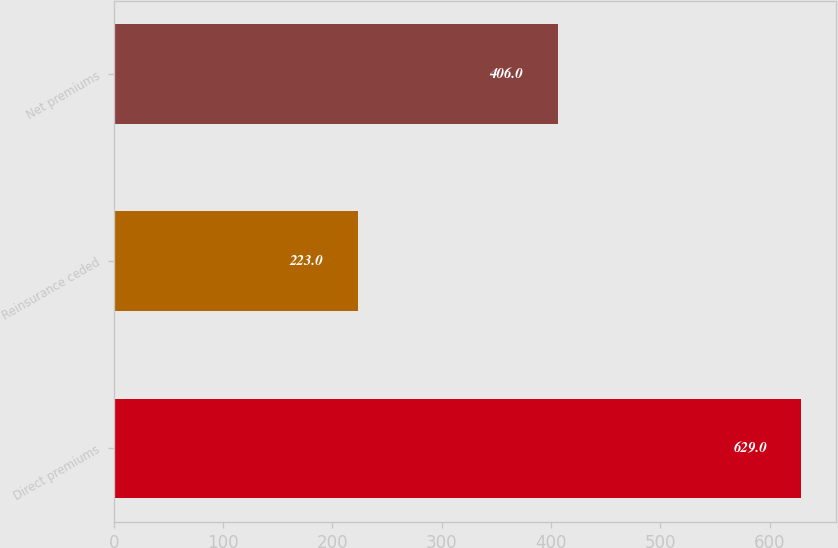Convert chart. <chart><loc_0><loc_0><loc_500><loc_500><bar_chart><fcel>Direct premiums<fcel>Reinsurance ceded<fcel>Net premiums<nl><fcel>629<fcel>223<fcel>406<nl></chart> 